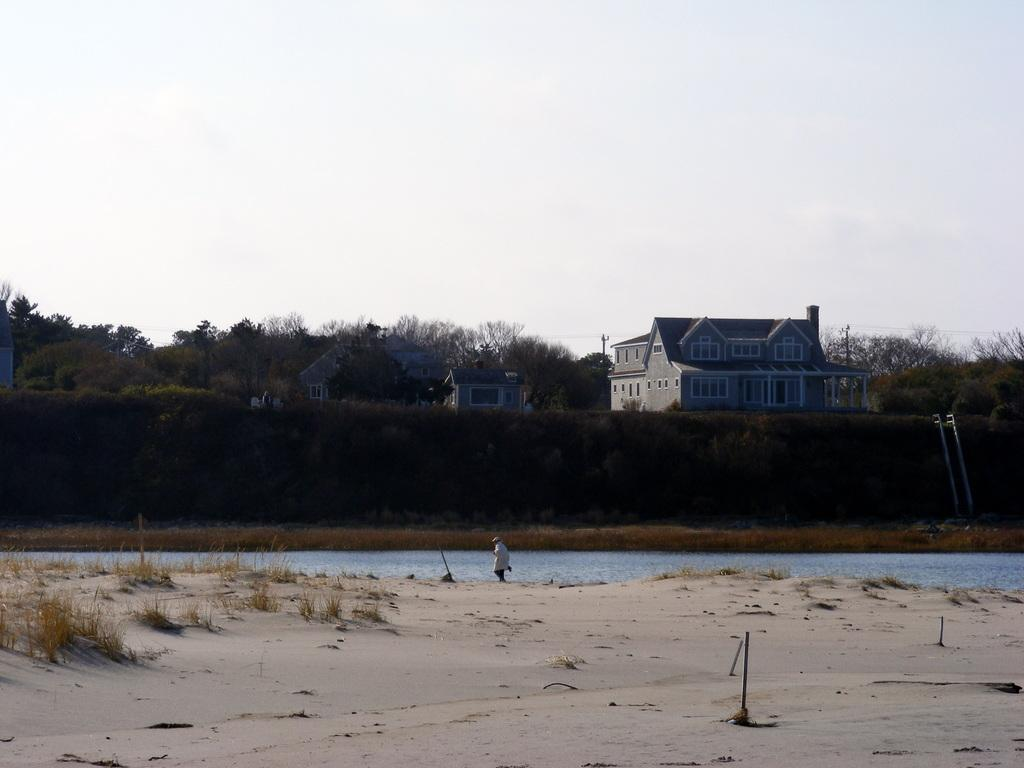What type of natural environment is depicted at the bottom side of the image? There is sand and water at the bottom side of the image. What structures can be seen in the center of the image? There are houses in the center of the image. What type of vegetation is present in the center of the image? There are trees in the center of the image. What type of stamp can be seen on the houses in the image? There is no stamp present on the houses in the image. What kind of seeds are being planted in the sand and water at the bottom side of the image? There are no seeds being planted in the image; it depicts sand and water. 